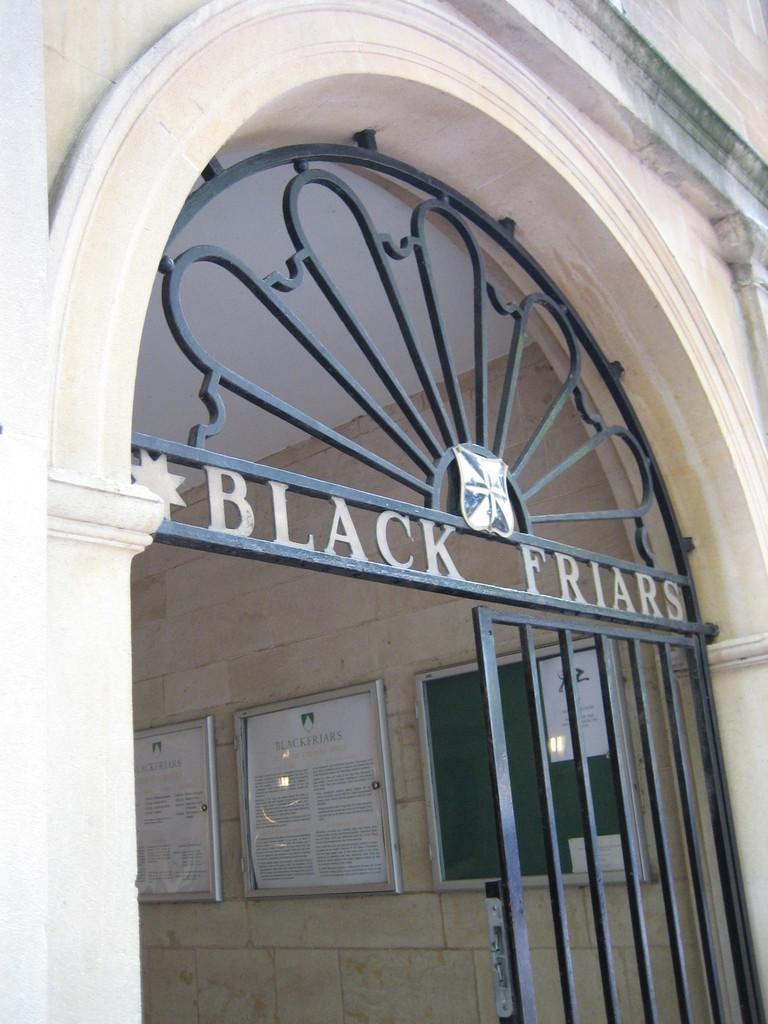How would you summarize this image in a sentence or two? In this image we can see gate, arch and stone walls where a few boards are placed in the background. 